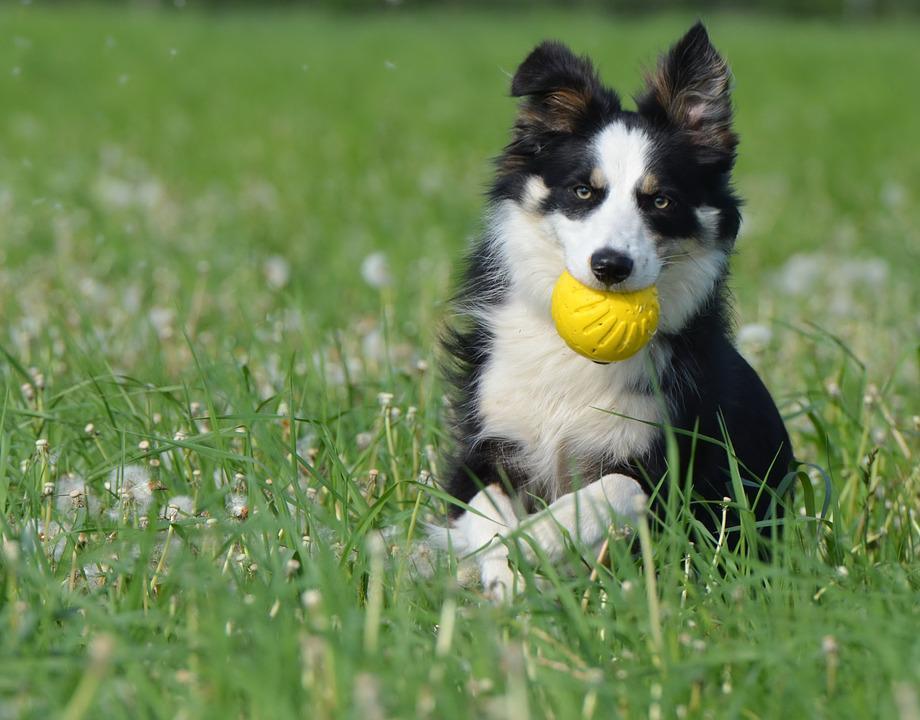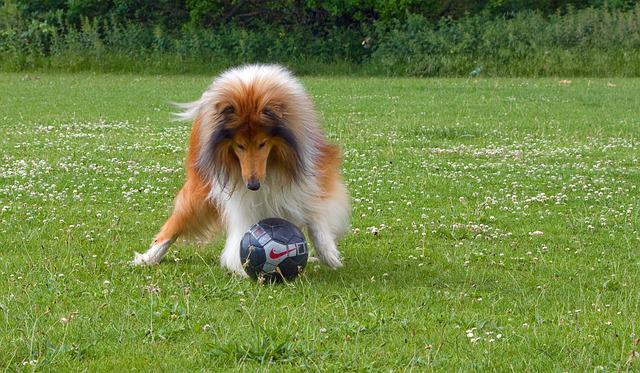The first image is the image on the left, the second image is the image on the right. Analyze the images presented: Is the assertion "An image shows one dog posed in the grass with a yellow ball." valid? Answer yes or no. Yes. 